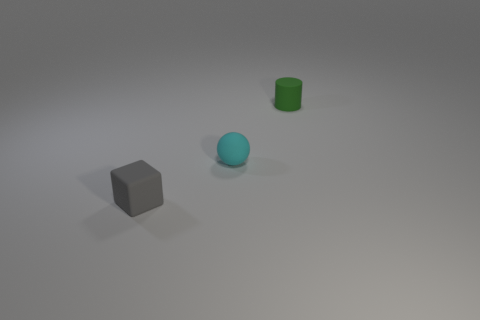Add 1 red rubber cubes. How many objects exist? 4 Subtract all blocks. How many objects are left? 2 Add 1 tiny green objects. How many tiny green objects are left? 2 Add 1 tiny gray blocks. How many tiny gray blocks exist? 2 Subtract 0 yellow cylinders. How many objects are left? 3 Subtract all brown cubes. Subtract all gray rubber objects. How many objects are left? 2 